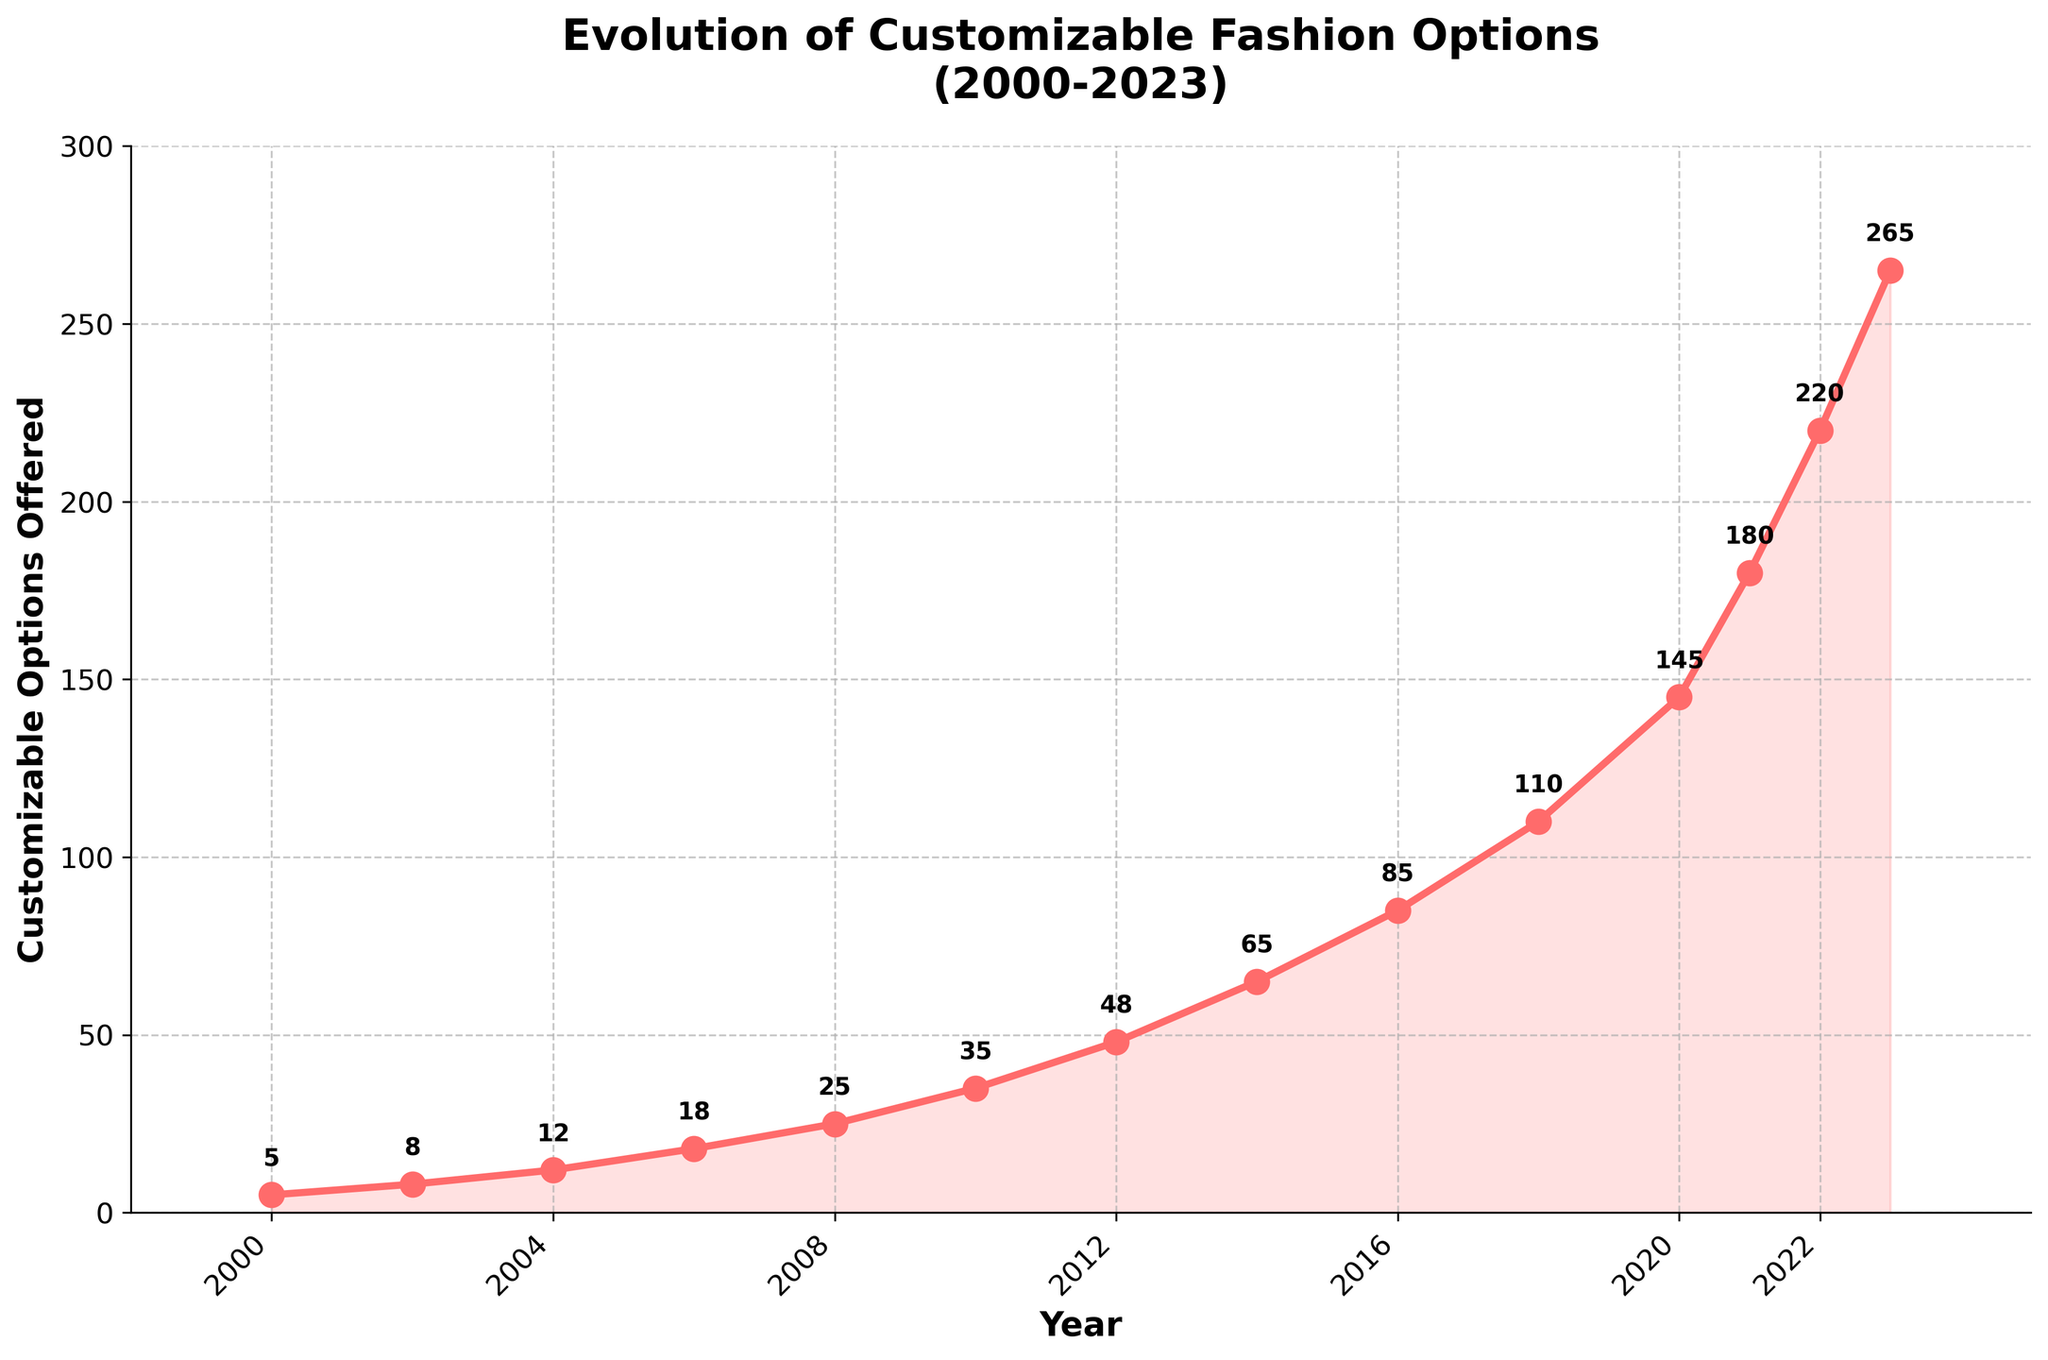Which year saw the largest increase in customizable fashion options compared to the previous year? The biggest jump will be identified by calculating the difference between consecutive years and comparing them. The increase from 2021 to 2022 was 220 - 180 = 40, and from 2022 to 2023 was 265 - 220 = 45. This is the highest annual increase in the dataset.
Answer: 2023 From 2000 to 2023, which year had the smallest growth in customizable options compared to the previous year? By comparing the increases for each year, the smallest growth occurs from 2000 to 2002, which is 8 - 5 = 3.
Answer: 2002 How many options were available in total from 2000 to 2006? To get the total, add the values from 2000 to 2006: 5 + 8 + 12 + 18 = 43.
Answer: 43 How many options were there between 2018 and 2022? Adding the values from 2018 to 2022: 110 + 145 + 180 + 220 = 655.
Answer: 655 What is the average number of customizable options offered from 2010 to 2016? Calculate the average of the values: (35 + 48 + 65 + 85) / 4 = 58.25.
Answer: 58.25 Which year shows the number of customizable options reaching over 100 for the first time? The first year to exceed 100 options is 2018 with 110 options.
Answer: 2018 What trend do you observe in the progression of customizable fashion options from 2000 to 2023? The graph indicates a continuously increasing trend with significant growth, especially after 2008.
Answer: Increasing trend How many options were offered in 2022 compared to 2020? The options in 2022 were 220 and in 2020 were 145, so 220 - 145 = 75.
Answer: 75 What is the color of the line used to depict the customizable options in the chart? The line on the chart is colored red.
Answer: Red 